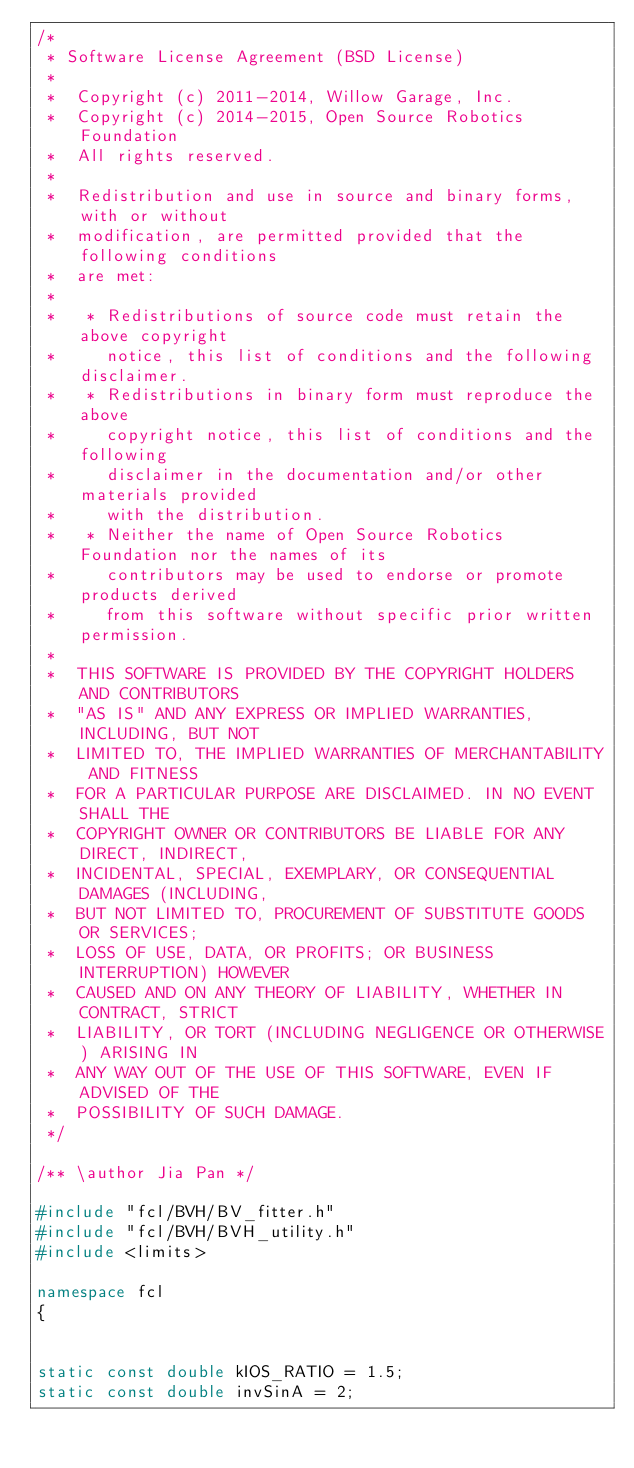<code> <loc_0><loc_0><loc_500><loc_500><_C++_>/*
 * Software License Agreement (BSD License)
 *
 *  Copyright (c) 2011-2014, Willow Garage, Inc.
 *  Copyright (c) 2014-2015, Open Source Robotics Foundation
 *  All rights reserved.
 *
 *  Redistribution and use in source and binary forms, with or without
 *  modification, are permitted provided that the following conditions
 *  are met:
 *
 *   * Redistributions of source code must retain the above copyright
 *     notice, this list of conditions and the following disclaimer.
 *   * Redistributions in binary form must reproduce the above
 *     copyright notice, this list of conditions and the following
 *     disclaimer in the documentation and/or other materials provided
 *     with the distribution.
 *   * Neither the name of Open Source Robotics Foundation nor the names of its
 *     contributors may be used to endorse or promote products derived
 *     from this software without specific prior written permission.
 *
 *  THIS SOFTWARE IS PROVIDED BY THE COPYRIGHT HOLDERS AND CONTRIBUTORS
 *  "AS IS" AND ANY EXPRESS OR IMPLIED WARRANTIES, INCLUDING, BUT NOT
 *  LIMITED TO, THE IMPLIED WARRANTIES OF MERCHANTABILITY AND FITNESS
 *  FOR A PARTICULAR PURPOSE ARE DISCLAIMED. IN NO EVENT SHALL THE
 *  COPYRIGHT OWNER OR CONTRIBUTORS BE LIABLE FOR ANY DIRECT, INDIRECT,
 *  INCIDENTAL, SPECIAL, EXEMPLARY, OR CONSEQUENTIAL DAMAGES (INCLUDING,
 *  BUT NOT LIMITED TO, PROCUREMENT OF SUBSTITUTE GOODS OR SERVICES;
 *  LOSS OF USE, DATA, OR PROFITS; OR BUSINESS INTERRUPTION) HOWEVER
 *  CAUSED AND ON ANY THEORY OF LIABILITY, WHETHER IN CONTRACT, STRICT
 *  LIABILITY, OR TORT (INCLUDING NEGLIGENCE OR OTHERWISE) ARISING IN
 *  ANY WAY OUT OF THE USE OF THIS SOFTWARE, EVEN IF ADVISED OF THE
 *  POSSIBILITY OF SUCH DAMAGE.
 */

/** \author Jia Pan */

#include "fcl/BVH/BV_fitter.h"
#include "fcl/BVH/BVH_utility.h"
#include <limits>

namespace fcl
{


static const double kIOS_RATIO = 1.5;
static const double invSinA = 2;</code> 